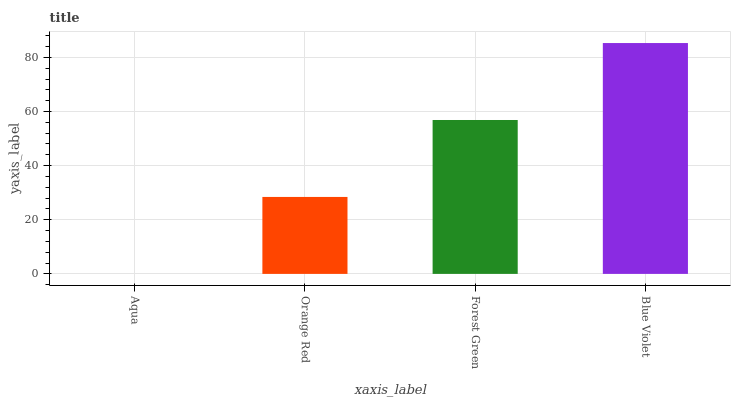Is Aqua the minimum?
Answer yes or no. Yes. Is Blue Violet the maximum?
Answer yes or no. Yes. Is Orange Red the minimum?
Answer yes or no. No. Is Orange Red the maximum?
Answer yes or no. No. Is Orange Red greater than Aqua?
Answer yes or no. Yes. Is Aqua less than Orange Red?
Answer yes or no. Yes. Is Aqua greater than Orange Red?
Answer yes or no. No. Is Orange Red less than Aqua?
Answer yes or no. No. Is Forest Green the high median?
Answer yes or no. Yes. Is Orange Red the low median?
Answer yes or no. Yes. Is Blue Violet the high median?
Answer yes or no. No. Is Blue Violet the low median?
Answer yes or no. No. 